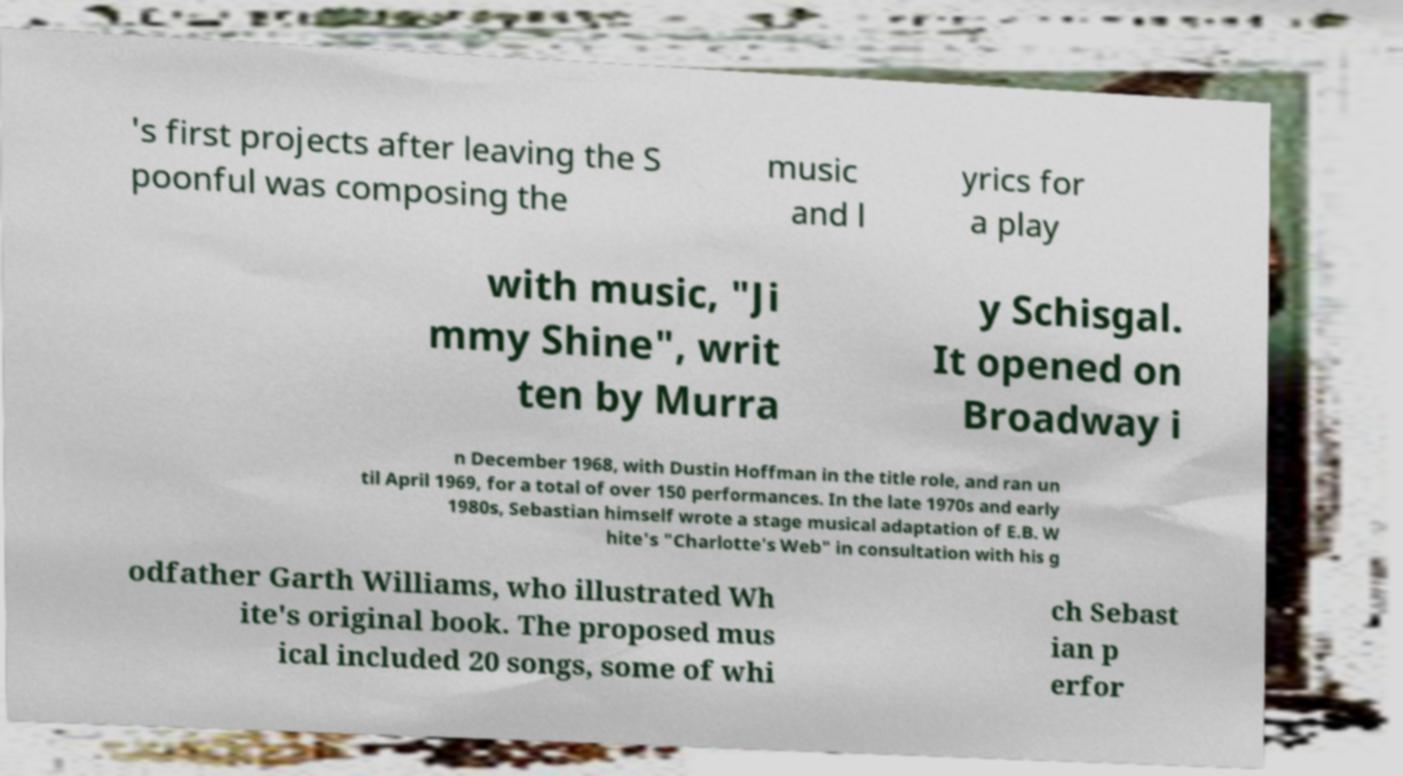Can you accurately transcribe the text from the provided image for me? 's first projects after leaving the S poonful was composing the music and l yrics for a play with music, "Ji mmy Shine", writ ten by Murra y Schisgal. It opened on Broadway i n December 1968, with Dustin Hoffman in the title role, and ran un til April 1969, for a total of over 150 performances. In the late 1970s and early 1980s, Sebastian himself wrote a stage musical adaptation of E.B. W hite's "Charlotte's Web" in consultation with his g odfather Garth Williams, who illustrated Wh ite's original book. The proposed mus ical included 20 songs, some of whi ch Sebast ian p erfor 